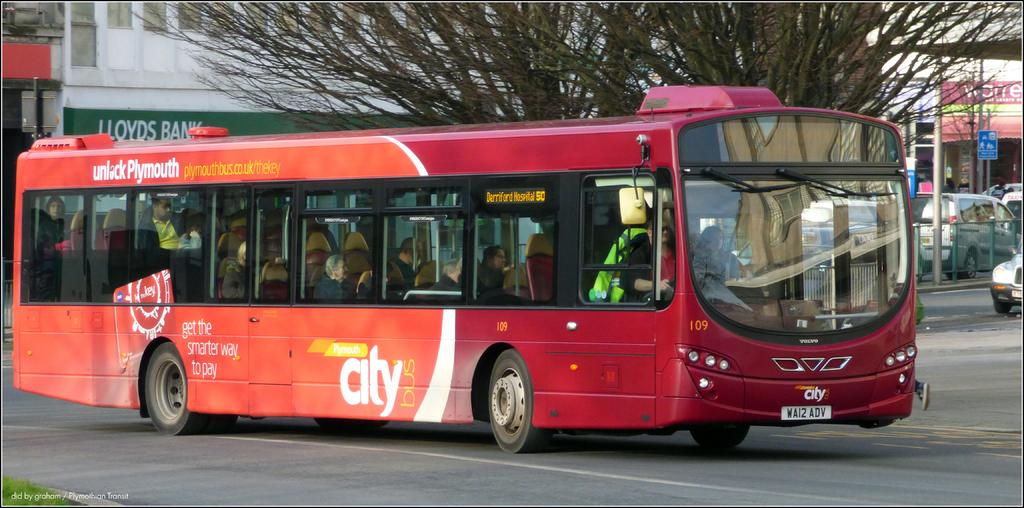<image>
Relay a brief, clear account of the picture shown. The bus advertised here is a red bus advertising get the smarter way to pay. 